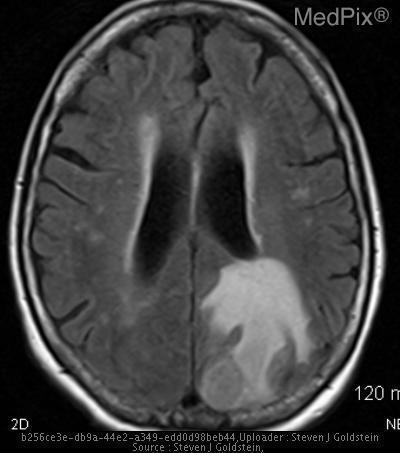How many ring enhancing lesions can be found in this image?
Give a very brief answer. One. What is the secondary pathology?
Concise answer only. Moderate edema. What is the secondary abnormality in this image?
Answer briefly. Moderate edema. What is the primary abnormality in this image?
Keep it brief. Ring enhancing lesion in the left occipital lobe. What is the primary pathology
Short answer required. Ring enhancing lesion in the left occipital lobe. How would you characterize the lesion?
Keep it brief. Ring enhancing lesion. What is the characterization of the lesion
Write a very short answer. Ring enhancing lesion. 